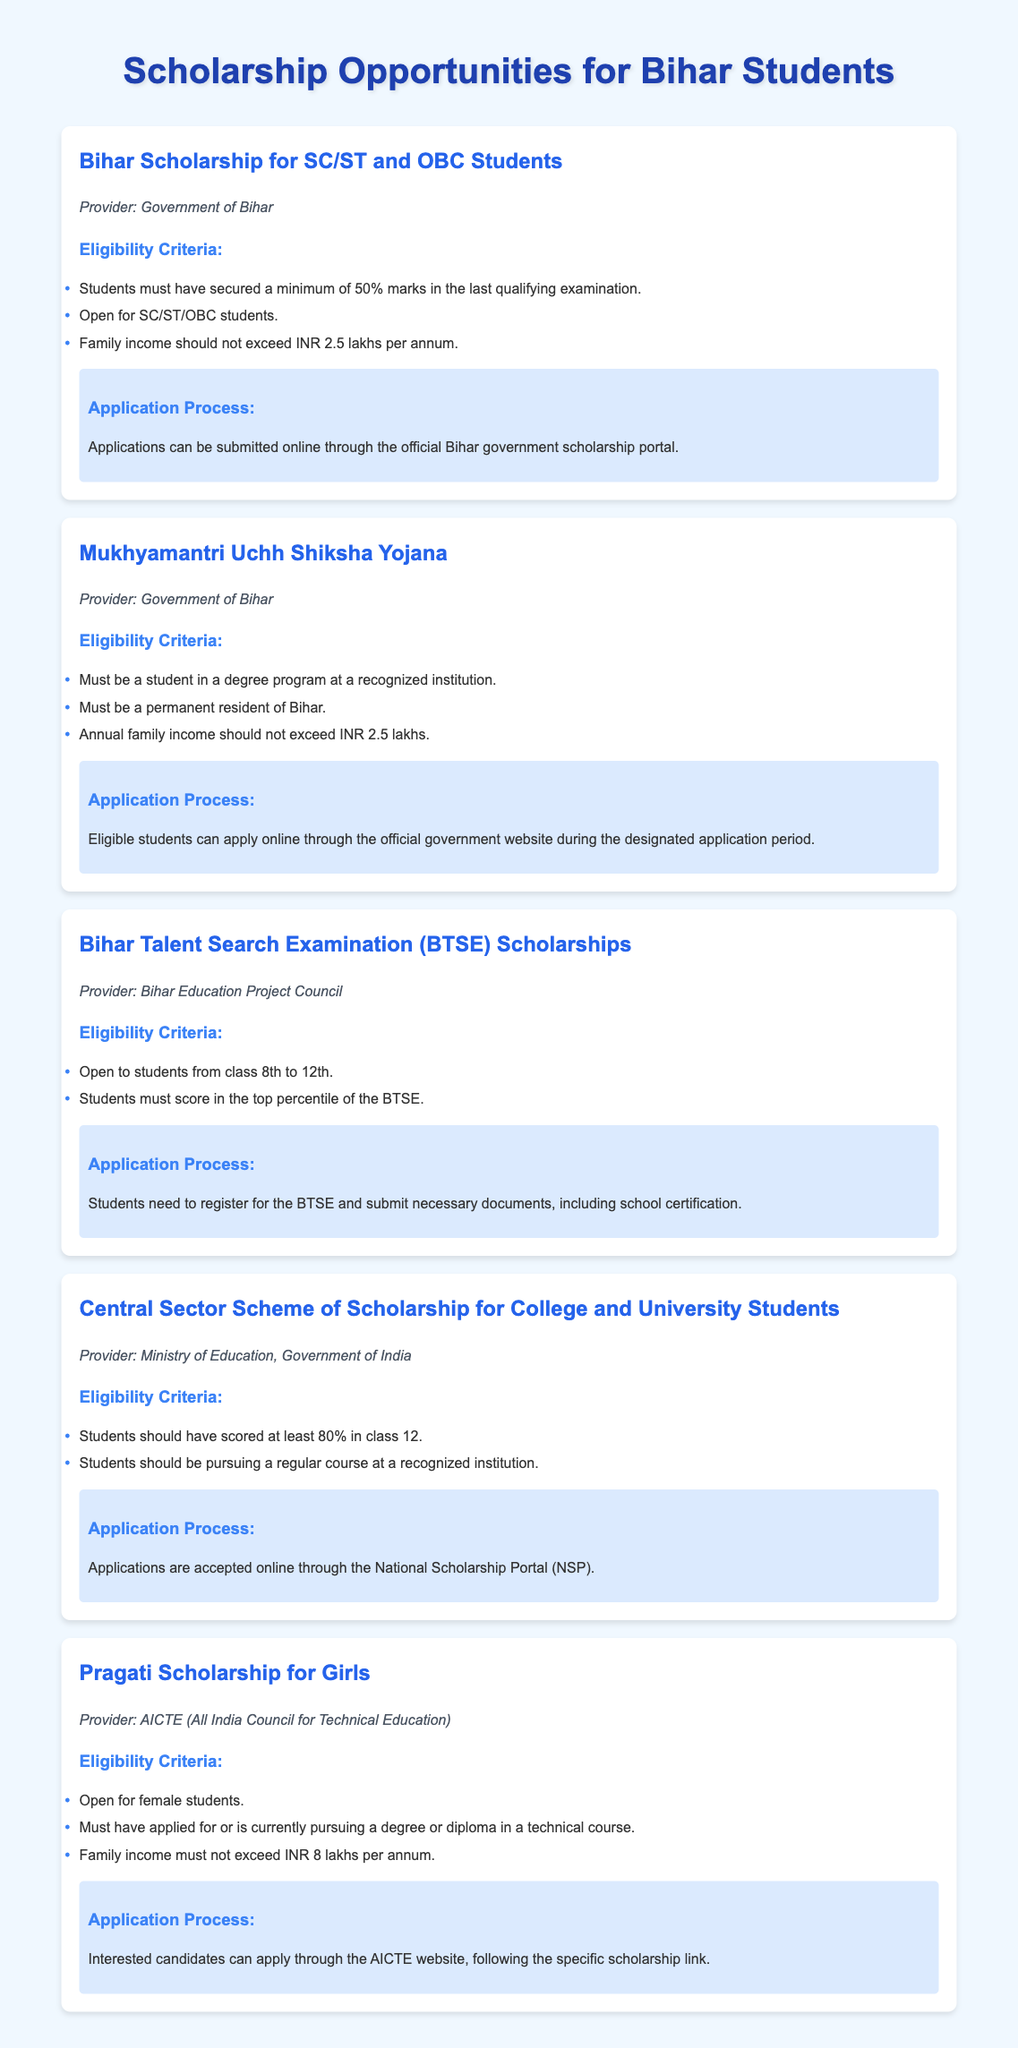What is the income limit for Bihar SC/ST and OBC scholarship? The document states that the family income should not exceed INR 2.5 lakhs per annum.
Answer: INR 2.5 lakhs Who provides the Mukhyamantri Uchh Shiksha Yojana? The scholarship is provided by the Government of Bihar.
Answer: Government of Bihar What is the eligibility percentage for the Central Sector Scheme of Scholarship? Students should have scored at least 80% in class 12 to be eligible for this scholarship.
Answer: 80% Which organization sponsors the Bihar Talent Search Examination Scholarships? The Bihar Education Project Council is the provider of these scholarships.
Answer: Bihar Education Project Council What type of students can apply for the Pragati Scholarship? The scholarship is open for female students pursuing technical courses.
Answer: Female students How can students apply for the Bihar SC/ST and OBC scholarship? Applications can be submitted online through the official Bihar government scholarship portal.
Answer: Online portal What is the purpose of the Pragati Scholarship? The Pragati Scholarship supports female students in technical courses.
Answer: Support for female students What grades are eligible for the Bihar Talent Search Examination? The scholarships are open to students from class 8th to 12th.
Answer: Class 8th to 12th 